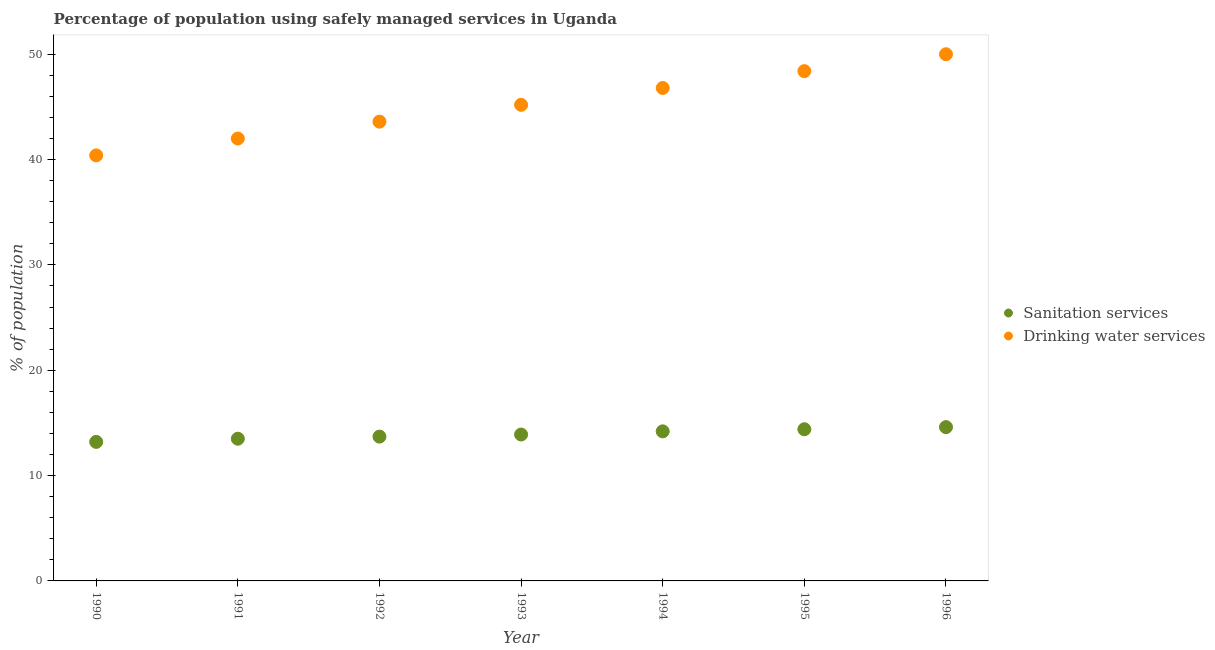Is the number of dotlines equal to the number of legend labels?
Ensure brevity in your answer.  Yes. Across all years, what is the minimum percentage of population who used sanitation services?
Provide a succinct answer. 13.2. In which year was the percentage of population who used sanitation services maximum?
Give a very brief answer. 1996. In which year was the percentage of population who used drinking water services minimum?
Keep it short and to the point. 1990. What is the total percentage of population who used sanitation services in the graph?
Ensure brevity in your answer.  97.5. What is the difference between the percentage of population who used sanitation services in 1994 and that in 1995?
Keep it short and to the point. -0.2. What is the difference between the percentage of population who used sanitation services in 1992 and the percentage of population who used drinking water services in 1995?
Keep it short and to the point. -34.7. What is the average percentage of population who used sanitation services per year?
Your answer should be very brief. 13.93. In the year 1995, what is the difference between the percentage of population who used drinking water services and percentage of population who used sanitation services?
Provide a succinct answer. 34. In how many years, is the percentage of population who used drinking water services greater than 18 %?
Your answer should be very brief. 7. What is the ratio of the percentage of population who used drinking water services in 1990 to that in 1991?
Keep it short and to the point. 0.96. What is the difference between the highest and the second highest percentage of population who used drinking water services?
Make the answer very short. 1.6. What is the difference between the highest and the lowest percentage of population who used drinking water services?
Your answer should be compact. 9.6. In how many years, is the percentage of population who used drinking water services greater than the average percentage of population who used drinking water services taken over all years?
Your response must be concise. 4. Is the percentage of population who used sanitation services strictly less than the percentage of population who used drinking water services over the years?
Provide a short and direct response. Yes. How many years are there in the graph?
Your answer should be compact. 7. How many legend labels are there?
Your answer should be very brief. 2. How are the legend labels stacked?
Your answer should be compact. Vertical. What is the title of the graph?
Ensure brevity in your answer.  Percentage of population using safely managed services in Uganda. What is the label or title of the X-axis?
Give a very brief answer. Year. What is the label or title of the Y-axis?
Ensure brevity in your answer.  % of population. What is the % of population of Sanitation services in 1990?
Make the answer very short. 13.2. What is the % of population of Drinking water services in 1990?
Make the answer very short. 40.4. What is the % of population of Drinking water services in 1992?
Your response must be concise. 43.6. What is the % of population in Drinking water services in 1993?
Provide a succinct answer. 45.2. What is the % of population of Drinking water services in 1994?
Provide a short and direct response. 46.8. What is the % of population of Sanitation services in 1995?
Provide a short and direct response. 14.4. What is the % of population in Drinking water services in 1995?
Make the answer very short. 48.4. Across all years, what is the maximum % of population in Sanitation services?
Make the answer very short. 14.6. Across all years, what is the minimum % of population in Drinking water services?
Your answer should be compact. 40.4. What is the total % of population in Sanitation services in the graph?
Give a very brief answer. 97.5. What is the total % of population of Drinking water services in the graph?
Offer a terse response. 316.4. What is the difference between the % of population of Sanitation services in 1990 and that in 1991?
Ensure brevity in your answer.  -0.3. What is the difference between the % of population in Drinking water services in 1990 and that in 1993?
Ensure brevity in your answer.  -4.8. What is the difference between the % of population in Sanitation services in 1990 and that in 1994?
Give a very brief answer. -1. What is the difference between the % of population in Drinking water services in 1990 and that in 1994?
Give a very brief answer. -6.4. What is the difference between the % of population of Drinking water services in 1990 and that in 1995?
Ensure brevity in your answer.  -8. What is the difference between the % of population in Sanitation services in 1990 and that in 1996?
Provide a short and direct response. -1.4. What is the difference between the % of population of Drinking water services in 1990 and that in 1996?
Your answer should be very brief. -9.6. What is the difference between the % of population in Drinking water services in 1991 and that in 1992?
Offer a terse response. -1.6. What is the difference between the % of population in Sanitation services in 1991 and that in 1993?
Offer a terse response. -0.4. What is the difference between the % of population in Drinking water services in 1991 and that in 1993?
Provide a short and direct response. -3.2. What is the difference between the % of population of Sanitation services in 1991 and that in 1994?
Provide a short and direct response. -0.7. What is the difference between the % of population in Drinking water services in 1991 and that in 1994?
Keep it short and to the point. -4.8. What is the difference between the % of population in Sanitation services in 1991 and that in 1996?
Provide a short and direct response. -1.1. What is the difference between the % of population of Drinking water services in 1991 and that in 1996?
Offer a very short reply. -8. What is the difference between the % of population in Drinking water services in 1992 and that in 1993?
Your answer should be very brief. -1.6. What is the difference between the % of population of Sanitation services in 1992 and that in 1994?
Your answer should be very brief. -0.5. What is the difference between the % of population of Sanitation services in 1992 and that in 1995?
Your response must be concise. -0.7. What is the difference between the % of population of Drinking water services in 1992 and that in 1995?
Give a very brief answer. -4.8. What is the difference between the % of population in Sanitation services in 1993 and that in 1994?
Make the answer very short. -0.3. What is the difference between the % of population in Sanitation services in 1993 and that in 1995?
Give a very brief answer. -0.5. What is the difference between the % of population in Drinking water services in 1993 and that in 1995?
Make the answer very short. -3.2. What is the difference between the % of population in Sanitation services in 1993 and that in 1996?
Offer a terse response. -0.7. What is the difference between the % of population of Drinking water services in 1993 and that in 1996?
Make the answer very short. -4.8. What is the difference between the % of population of Sanitation services in 1994 and that in 1995?
Offer a terse response. -0.2. What is the difference between the % of population in Drinking water services in 1994 and that in 1995?
Make the answer very short. -1.6. What is the difference between the % of population of Sanitation services in 1995 and that in 1996?
Your answer should be very brief. -0.2. What is the difference between the % of population of Sanitation services in 1990 and the % of population of Drinking water services in 1991?
Offer a very short reply. -28.8. What is the difference between the % of population in Sanitation services in 1990 and the % of population in Drinking water services in 1992?
Your response must be concise. -30.4. What is the difference between the % of population of Sanitation services in 1990 and the % of population of Drinking water services in 1993?
Ensure brevity in your answer.  -32. What is the difference between the % of population in Sanitation services in 1990 and the % of population in Drinking water services in 1994?
Provide a short and direct response. -33.6. What is the difference between the % of population of Sanitation services in 1990 and the % of population of Drinking water services in 1995?
Your answer should be compact. -35.2. What is the difference between the % of population of Sanitation services in 1990 and the % of population of Drinking water services in 1996?
Your answer should be compact. -36.8. What is the difference between the % of population of Sanitation services in 1991 and the % of population of Drinking water services in 1992?
Your answer should be very brief. -30.1. What is the difference between the % of population of Sanitation services in 1991 and the % of population of Drinking water services in 1993?
Keep it short and to the point. -31.7. What is the difference between the % of population of Sanitation services in 1991 and the % of population of Drinking water services in 1994?
Your answer should be very brief. -33.3. What is the difference between the % of population in Sanitation services in 1991 and the % of population in Drinking water services in 1995?
Your answer should be very brief. -34.9. What is the difference between the % of population in Sanitation services in 1991 and the % of population in Drinking water services in 1996?
Keep it short and to the point. -36.5. What is the difference between the % of population in Sanitation services in 1992 and the % of population in Drinking water services in 1993?
Your response must be concise. -31.5. What is the difference between the % of population of Sanitation services in 1992 and the % of population of Drinking water services in 1994?
Give a very brief answer. -33.1. What is the difference between the % of population of Sanitation services in 1992 and the % of population of Drinking water services in 1995?
Your answer should be compact. -34.7. What is the difference between the % of population in Sanitation services in 1992 and the % of population in Drinking water services in 1996?
Keep it short and to the point. -36.3. What is the difference between the % of population in Sanitation services in 1993 and the % of population in Drinking water services in 1994?
Keep it short and to the point. -32.9. What is the difference between the % of population of Sanitation services in 1993 and the % of population of Drinking water services in 1995?
Provide a short and direct response. -34.5. What is the difference between the % of population in Sanitation services in 1993 and the % of population in Drinking water services in 1996?
Offer a terse response. -36.1. What is the difference between the % of population in Sanitation services in 1994 and the % of population in Drinking water services in 1995?
Your answer should be very brief. -34.2. What is the difference between the % of population of Sanitation services in 1994 and the % of population of Drinking water services in 1996?
Your answer should be compact. -35.8. What is the difference between the % of population of Sanitation services in 1995 and the % of population of Drinking water services in 1996?
Keep it short and to the point. -35.6. What is the average % of population of Sanitation services per year?
Provide a short and direct response. 13.93. What is the average % of population in Drinking water services per year?
Provide a short and direct response. 45.2. In the year 1990, what is the difference between the % of population in Sanitation services and % of population in Drinking water services?
Keep it short and to the point. -27.2. In the year 1991, what is the difference between the % of population in Sanitation services and % of population in Drinking water services?
Your answer should be compact. -28.5. In the year 1992, what is the difference between the % of population in Sanitation services and % of population in Drinking water services?
Give a very brief answer. -29.9. In the year 1993, what is the difference between the % of population of Sanitation services and % of population of Drinking water services?
Provide a succinct answer. -31.3. In the year 1994, what is the difference between the % of population in Sanitation services and % of population in Drinking water services?
Give a very brief answer. -32.6. In the year 1995, what is the difference between the % of population of Sanitation services and % of population of Drinking water services?
Keep it short and to the point. -34. In the year 1996, what is the difference between the % of population in Sanitation services and % of population in Drinking water services?
Offer a terse response. -35.4. What is the ratio of the % of population in Sanitation services in 1990 to that in 1991?
Provide a short and direct response. 0.98. What is the ratio of the % of population in Drinking water services in 1990 to that in 1991?
Keep it short and to the point. 0.96. What is the ratio of the % of population in Sanitation services in 1990 to that in 1992?
Provide a succinct answer. 0.96. What is the ratio of the % of population of Drinking water services in 1990 to that in 1992?
Provide a succinct answer. 0.93. What is the ratio of the % of population of Sanitation services in 1990 to that in 1993?
Your response must be concise. 0.95. What is the ratio of the % of population in Drinking water services in 1990 to that in 1993?
Your answer should be compact. 0.89. What is the ratio of the % of population of Sanitation services in 1990 to that in 1994?
Your answer should be very brief. 0.93. What is the ratio of the % of population in Drinking water services in 1990 to that in 1994?
Provide a succinct answer. 0.86. What is the ratio of the % of population in Drinking water services in 1990 to that in 1995?
Offer a terse response. 0.83. What is the ratio of the % of population in Sanitation services in 1990 to that in 1996?
Give a very brief answer. 0.9. What is the ratio of the % of population of Drinking water services in 1990 to that in 1996?
Make the answer very short. 0.81. What is the ratio of the % of population of Sanitation services in 1991 to that in 1992?
Make the answer very short. 0.99. What is the ratio of the % of population of Drinking water services in 1991 to that in 1992?
Provide a succinct answer. 0.96. What is the ratio of the % of population in Sanitation services in 1991 to that in 1993?
Your answer should be compact. 0.97. What is the ratio of the % of population in Drinking water services in 1991 to that in 1993?
Your answer should be very brief. 0.93. What is the ratio of the % of population in Sanitation services in 1991 to that in 1994?
Provide a succinct answer. 0.95. What is the ratio of the % of population of Drinking water services in 1991 to that in 1994?
Ensure brevity in your answer.  0.9. What is the ratio of the % of population of Sanitation services in 1991 to that in 1995?
Provide a succinct answer. 0.94. What is the ratio of the % of population in Drinking water services in 1991 to that in 1995?
Your answer should be compact. 0.87. What is the ratio of the % of population of Sanitation services in 1991 to that in 1996?
Your answer should be compact. 0.92. What is the ratio of the % of population in Drinking water services in 1991 to that in 1996?
Offer a terse response. 0.84. What is the ratio of the % of population in Sanitation services in 1992 to that in 1993?
Provide a short and direct response. 0.99. What is the ratio of the % of population in Drinking water services in 1992 to that in 1993?
Provide a short and direct response. 0.96. What is the ratio of the % of population in Sanitation services in 1992 to that in 1994?
Offer a terse response. 0.96. What is the ratio of the % of population in Drinking water services in 1992 to that in 1994?
Your answer should be very brief. 0.93. What is the ratio of the % of population in Sanitation services in 1992 to that in 1995?
Make the answer very short. 0.95. What is the ratio of the % of population in Drinking water services in 1992 to that in 1995?
Offer a very short reply. 0.9. What is the ratio of the % of population in Sanitation services in 1992 to that in 1996?
Give a very brief answer. 0.94. What is the ratio of the % of population of Drinking water services in 1992 to that in 1996?
Give a very brief answer. 0.87. What is the ratio of the % of population in Sanitation services in 1993 to that in 1994?
Provide a succinct answer. 0.98. What is the ratio of the % of population in Drinking water services in 1993 to that in 1994?
Provide a succinct answer. 0.97. What is the ratio of the % of population of Sanitation services in 1993 to that in 1995?
Your answer should be very brief. 0.97. What is the ratio of the % of population of Drinking water services in 1993 to that in 1995?
Offer a terse response. 0.93. What is the ratio of the % of population of Sanitation services in 1993 to that in 1996?
Keep it short and to the point. 0.95. What is the ratio of the % of population in Drinking water services in 1993 to that in 1996?
Provide a short and direct response. 0.9. What is the ratio of the % of population in Sanitation services in 1994 to that in 1995?
Make the answer very short. 0.99. What is the ratio of the % of population in Drinking water services in 1994 to that in 1995?
Your answer should be compact. 0.97. What is the ratio of the % of population of Sanitation services in 1994 to that in 1996?
Ensure brevity in your answer.  0.97. What is the ratio of the % of population in Drinking water services in 1994 to that in 1996?
Offer a terse response. 0.94. What is the ratio of the % of population of Sanitation services in 1995 to that in 1996?
Ensure brevity in your answer.  0.99. What is the difference between the highest and the second highest % of population of Sanitation services?
Your answer should be compact. 0.2. What is the difference between the highest and the second highest % of population in Drinking water services?
Offer a terse response. 1.6. What is the difference between the highest and the lowest % of population in Sanitation services?
Your answer should be very brief. 1.4. 